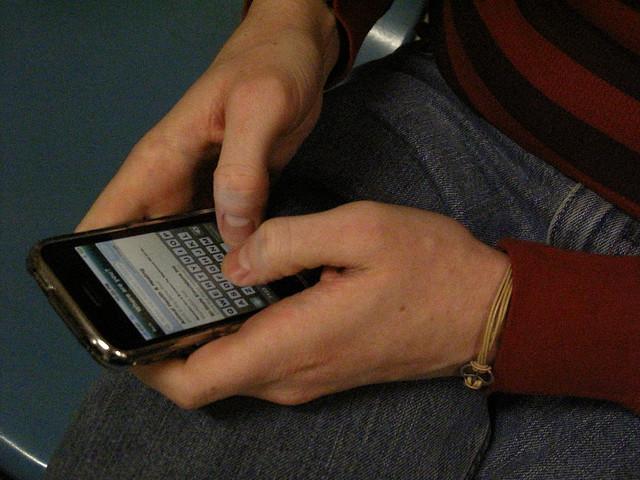What is this person holding in left hand?
Quick response, please. Phone. What is in the person's hands?
Give a very brief answer. Cell phone. Does the person have a bracelet on?
Be succinct. Yes. Is the person texting?
Short answer required. Yes. What type of electronics is this?
Answer briefly. Smartphone. 